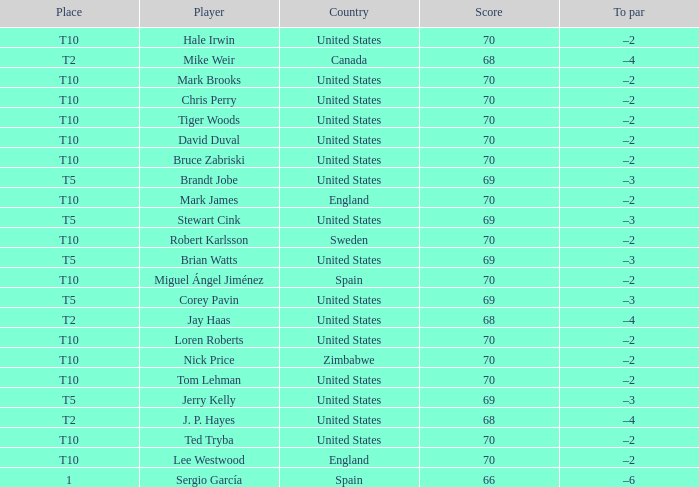What place did player mark brooks take? T10. 